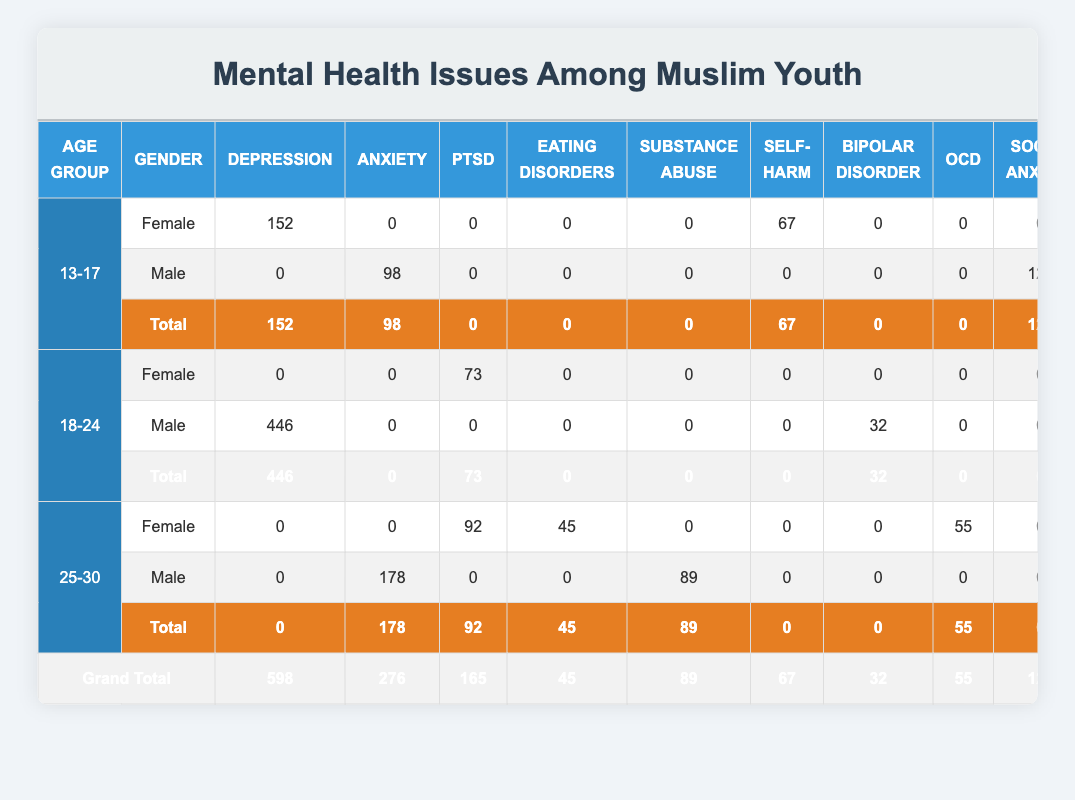What is the total number of reported cases of depression among Muslim youth in the 13-17 age group? In the 13-17 age group, the reported cases of depression are 152 for females and 0 for males. Adding these gives 152 + 0 = 152.
Answer: 152 Which age group has the highest total number of reported mental health issues? Summing the reported cases for each age group: 525 for 13-17, 569 for 18-24, and 459 for 25-30. The highest value is 569, which corresponds to the 18-24 age group.
Answer: 18-24 Is there any reported case of schizophrenia among Muslim youth in the 25-30 age group? The table shows that there are 0 cases of schizophrenia reported for both females and males in the 25-30 age group, confirming that there are no cases.
Answer: No What is the average number of reported cases of anxiety across all age groups and genders? The total reported cases of anxiety are 276. There are two data points for anxiety (across males and females in all age groups). Therefore, the average is 276 / 2 = 138.
Answer: 138 How many more cases of anxiety are reported compared to self-harm in the 13-17 age group? For the 13-17 age group, anxiety has 98 reported cases (male), and self-harm has 67 reported cases (female). The difference is 98 - 67 = 31.
Answer: 31 What is the total number of cases reported for eating disorders across all age groups? Only the 25-30 age group has reported cases of eating disorders, with 45 cases for females. Therefore, the total is 45.
Answer: 45 Which region has the highest number of reported cases of depression? The reported cases for depression by region are 152 in North America (for females in 13-17) and 201 in the Middle East (for males in 18-24). The highest is 201 in the Middle East.
Answer: Middle East Are there any reported cases of bipolar disorder in the 13-17 age group? The table indicates that there are 0 cases of bipolar disorder reported in the 13-17 age group for both genders.
Answer: No 